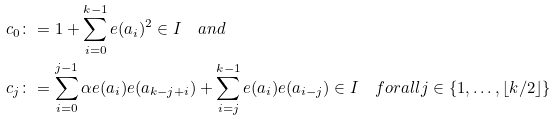<formula> <loc_0><loc_0><loc_500><loc_500>c _ { 0 } & \colon = 1 + \sum _ { i = 0 } ^ { k - 1 } e ( a _ { i } ) ^ { 2 } \in I \quad a n d \\ c _ { j } & \colon = \sum _ { i = 0 } ^ { j - 1 } \alpha e ( a _ { i } ) e ( a _ { k - j + i } ) + \sum _ { i = j } ^ { k - 1 } e ( a _ { i } ) e ( a _ { i - j } ) \in I \quad f o r a l l j \in \{ 1 , \dots , \lfloor k / 2 \rfloor \}</formula> 